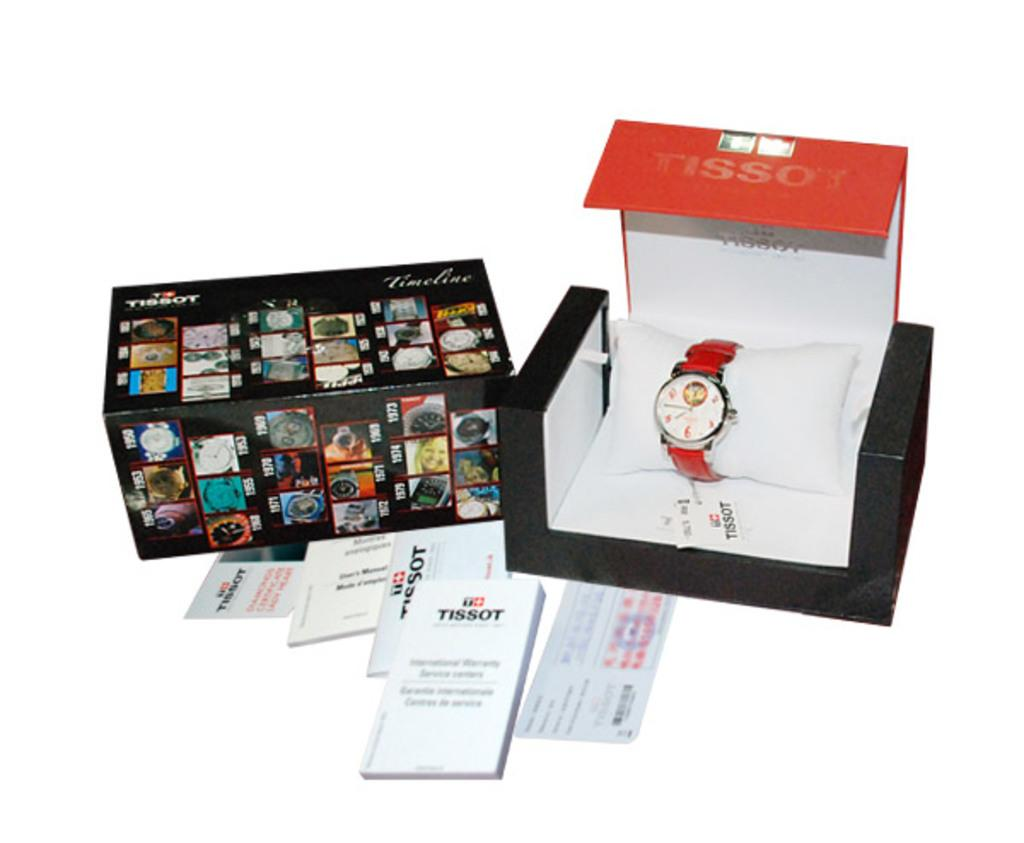<image>
Share a concise interpretation of the image provided. A Tissot watch complete with the box and pamphlets that came with it. 